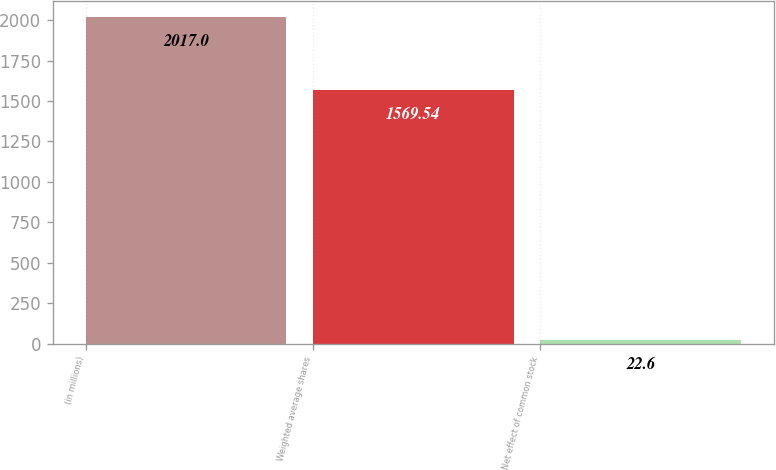Convert chart to OTSL. <chart><loc_0><loc_0><loc_500><loc_500><bar_chart><fcel>(in millions)<fcel>Weighted average shares<fcel>Net effect of common stock<nl><fcel>2017<fcel>1569.54<fcel>22.6<nl></chart> 